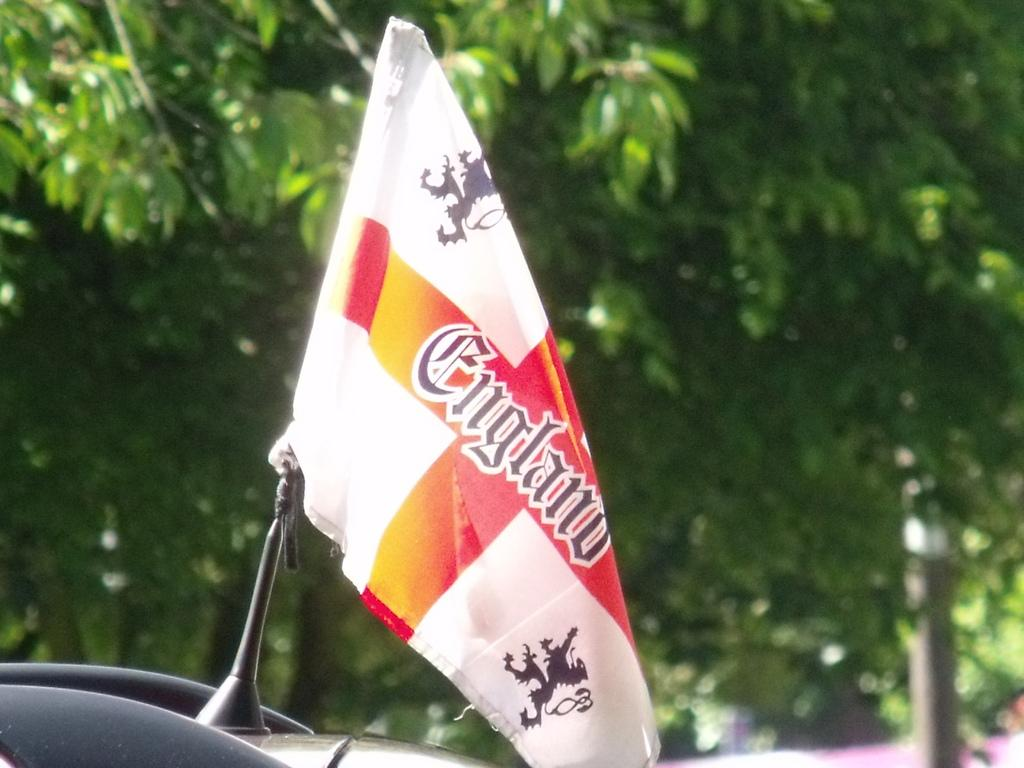What is hanging in the image? There is a flag hanging in the image. What else can be seen in the image besides the flag? There is a vehicle in the image. What can be seen in the background of the image? There are trees visible in the background of the image. How does the flag wave in the image? The flag does not wave in the image; it is hanging still. What type of government is depicted in the image? There is no indication of a government in the image; it only features a flag and a vehicle. 